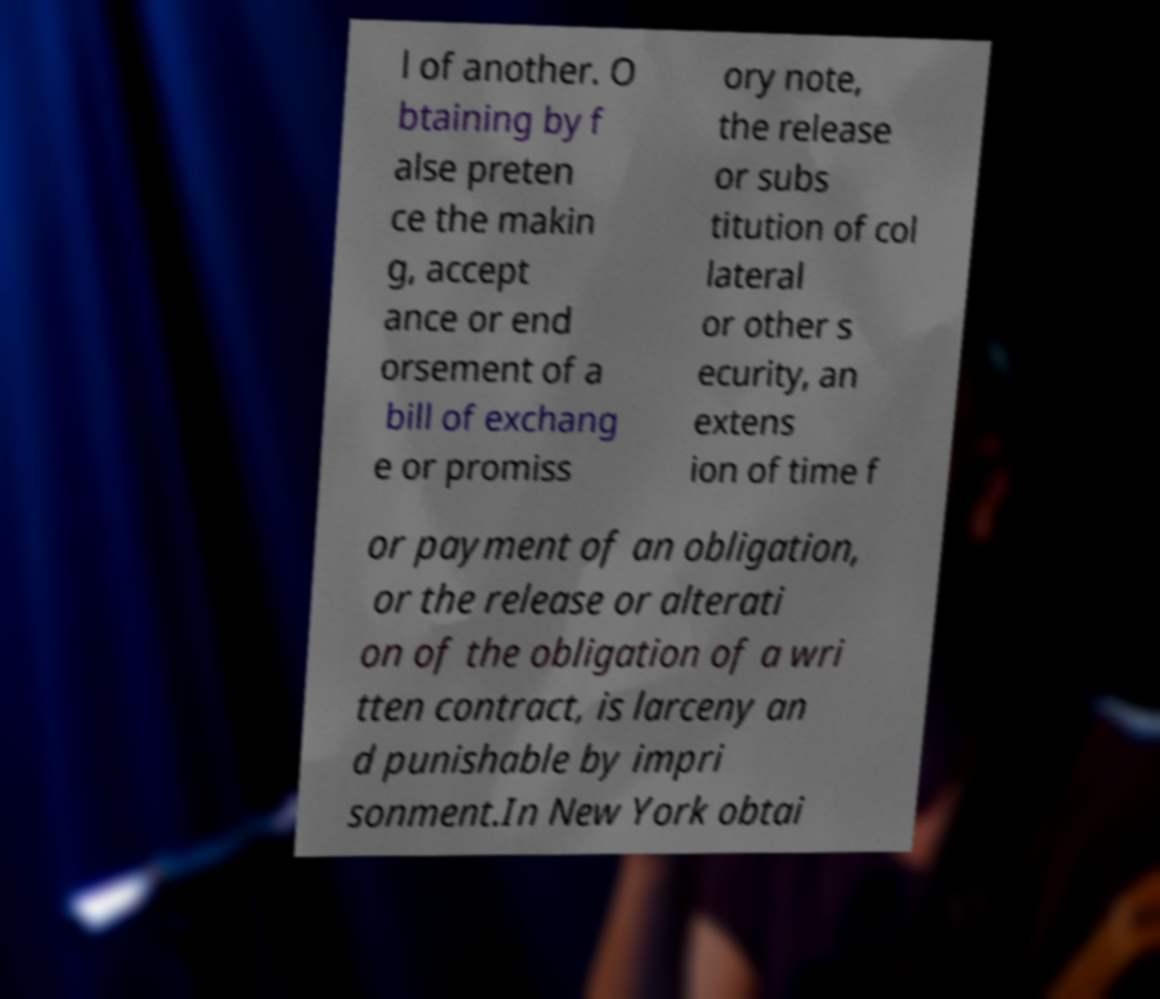Please read and relay the text visible in this image. What does it say? l of another. O btaining by f alse preten ce the makin g, accept ance or end orsement of a bill of exchang e or promiss ory note, the release or subs titution of col lateral or other s ecurity, an extens ion of time f or payment of an obligation, or the release or alterati on of the obligation of a wri tten contract, is larceny an d punishable by impri sonment.In New York obtai 